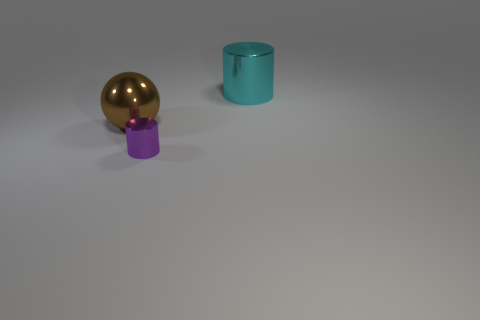What is the color of the cylinder that is to the right of the cylinder that is in front of the big metal thing that is left of the purple metallic thing? cyan 